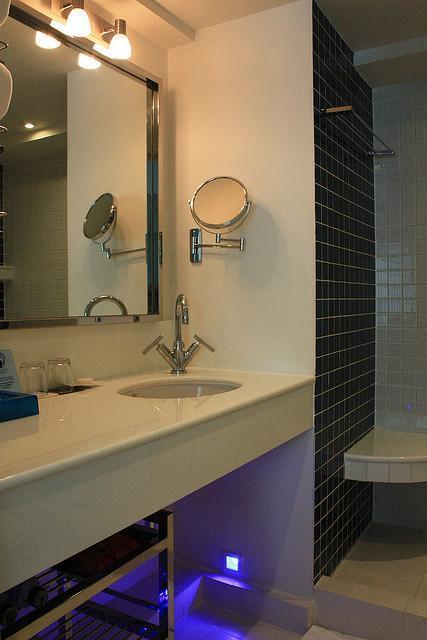How many mirrors are shown?
Give a very brief answer. 2. How many faucets are there?
Give a very brief answer. 1. 